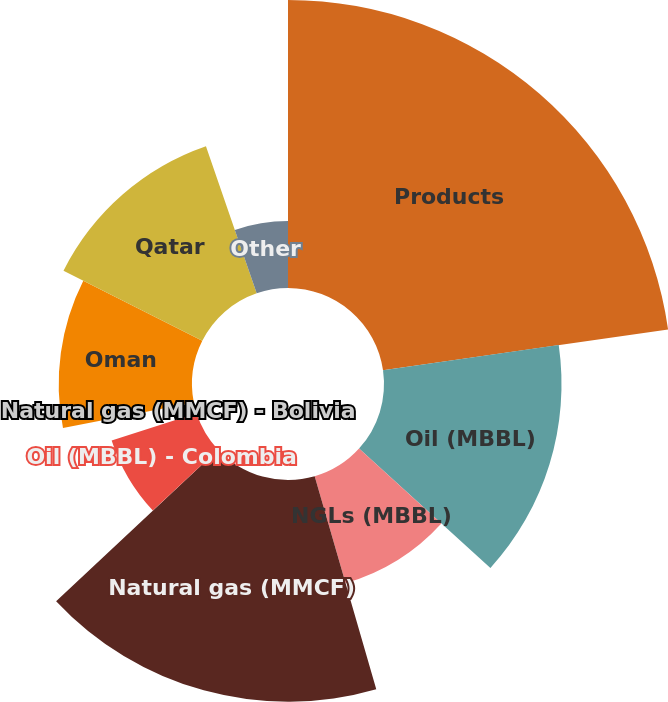Convert chart. <chart><loc_0><loc_0><loc_500><loc_500><pie_chart><fcel>Products<fcel>Oil (MBBL)<fcel>NGLs (MBBL)<fcel>Natural gas (MMCF)<fcel>Oil (MBBL) - Colombia<fcel>Natural gas (MMCF) - Bolivia<fcel>Dolphin<fcel>Oman<fcel>Qatar<fcel>Other<nl><fcel>22.73%<fcel>14.01%<fcel>8.78%<fcel>17.5%<fcel>7.04%<fcel>1.8%<fcel>0.06%<fcel>10.52%<fcel>12.27%<fcel>5.29%<nl></chart> 